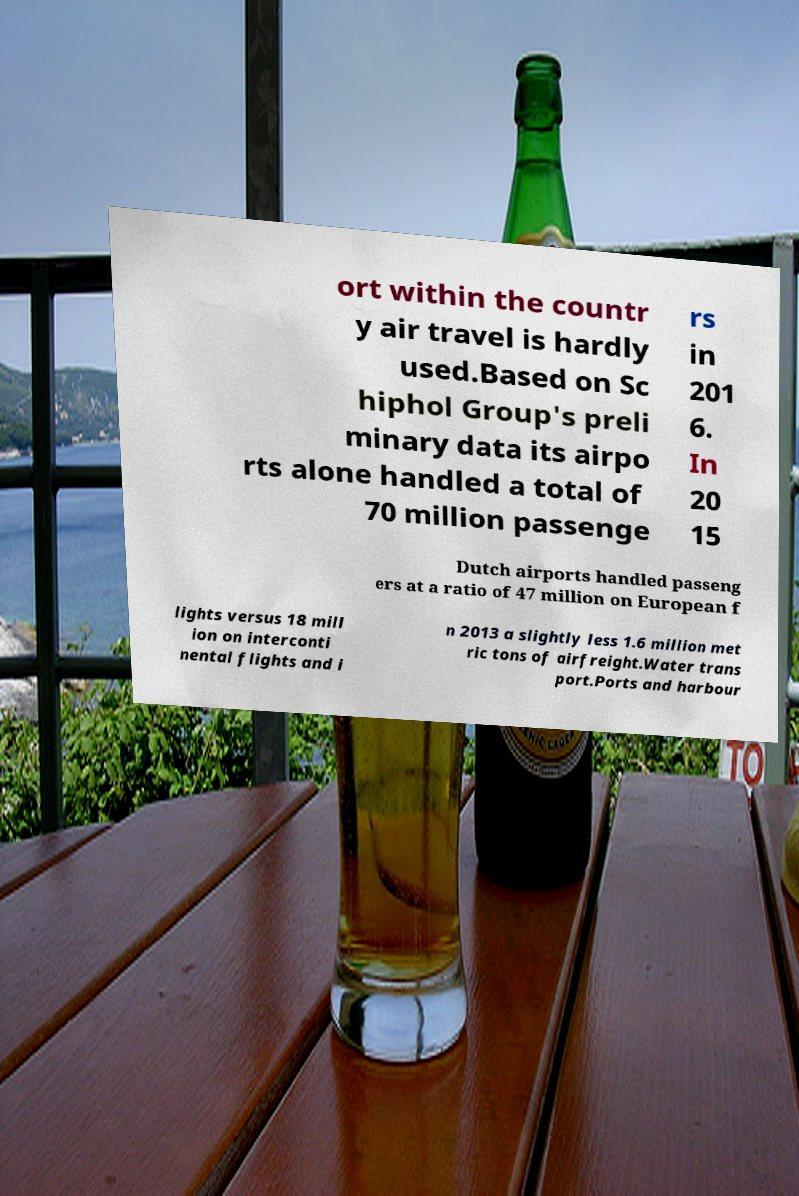Could you extract and type out the text from this image? ort within the countr y air travel is hardly used.Based on Sc hiphol Group's preli minary data its airpo rts alone handled a total of 70 million passenge rs in 201 6. In 20 15 Dutch airports handled passeng ers at a ratio of 47 million on European f lights versus 18 mill ion on interconti nental flights and i n 2013 a slightly less 1.6 million met ric tons of airfreight.Water trans port.Ports and harbour 